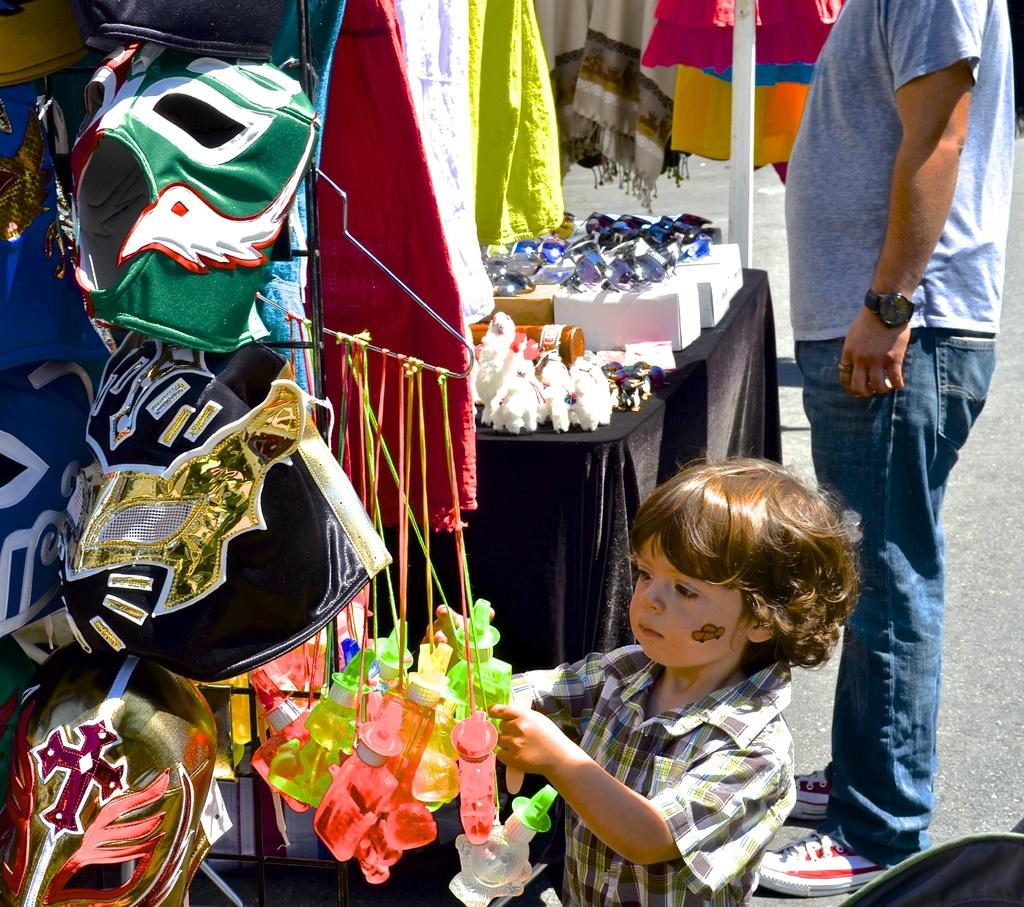Who is present in the image? There is a man and a kid in the image. What are the man and the kid doing in the image? Both the man and the kid are standing on a road. What can be seen in front of them? There are stalls in front of them. What type of beam is the doctor using to examine the market in the image? There is no doctor, market, or beam present in the image. 